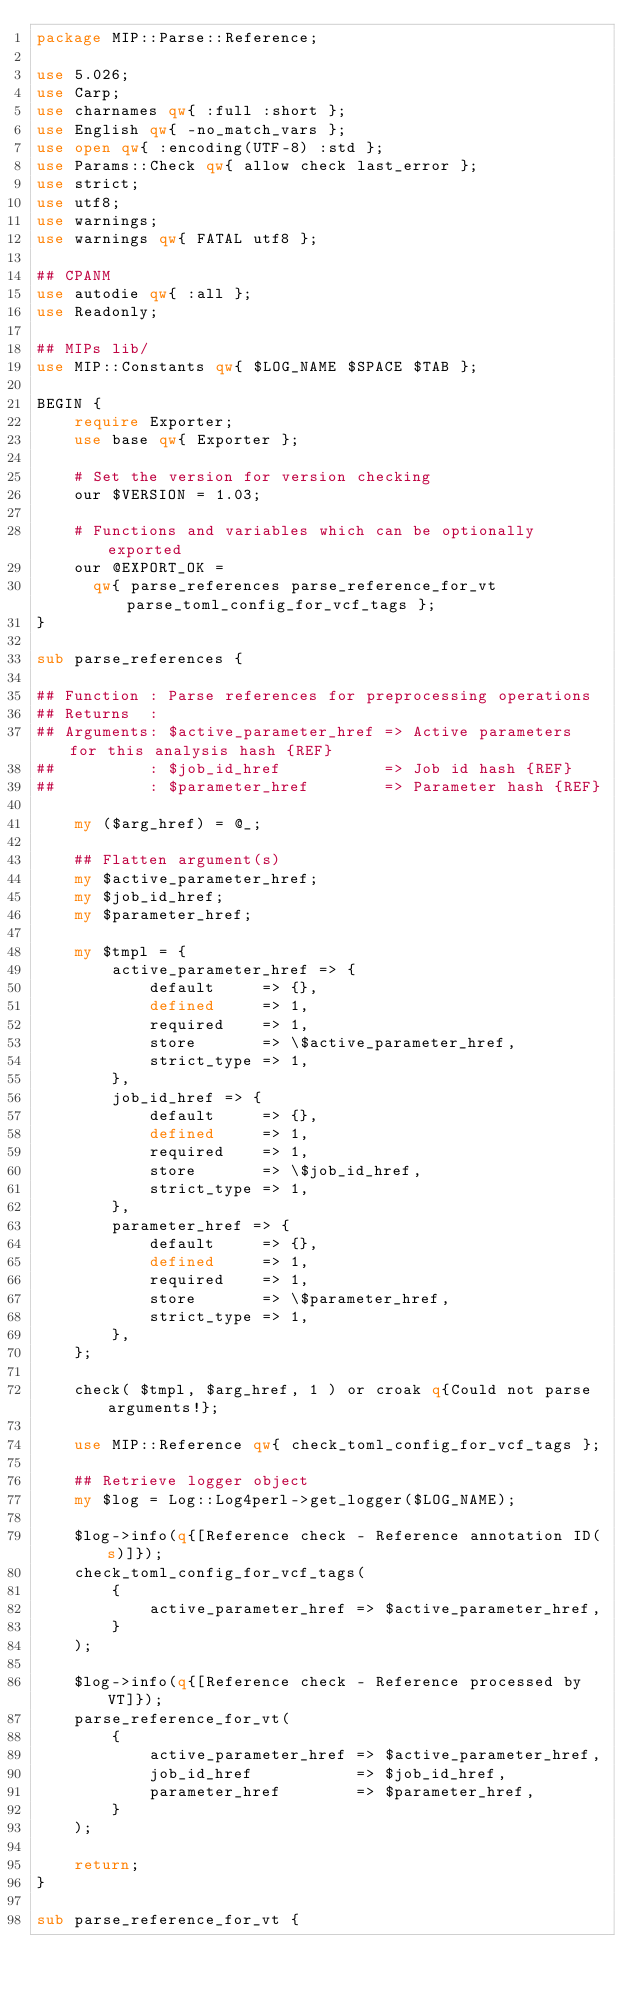Convert code to text. <code><loc_0><loc_0><loc_500><loc_500><_Perl_>package MIP::Parse::Reference;

use 5.026;
use Carp;
use charnames qw{ :full :short };
use English qw{ -no_match_vars };
use open qw{ :encoding(UTF-8) :std };
use Params::Check qw{ allow check last_error };
use strict;
use utf8;
use warnings;
use warnings qw{ FATAL utf8 };

## CPANM
use autodie qw{ :all };
use Readonly;

## MIPs lib/
use MIP::Constants qw{ $LOG_NAME $SPACE $TAB };

BEGIN {
    require Exporter;
    use base qw{ Exporter };

    # Set the version for version checking
    our $VERSION = 1.03;

    # Functions and variables which can be optionally exported
    our @EXPORT_OK =
      qw{ parse_references parse_reference_for_vt parse_toml_config_for_vcf_tags };
}

sub parse_references {

## Function : Parse references for preprocessing operations
## Returns  :
## Arguments: $active_parameter_href => Active parameters for this analysis hash {REF}
##          : $job_id_href           => Job id hash {REF}
##          : $parameter_href        => Parameter hash {REF}

    my ($arg_href) = @_;

    ## Flatten argument(s)
    my $active_parameter_href;
    my $job_id_href;
    my $parameter_href;

    my $tmpl = {
        active_parameter_href => {
            default     => {},
            defined     => 1,
            required    => 1,
            store       => \$active_parameter_href,
            strict_type => 1,
        },
        job_id_href => {
            default     => {},
            defined     => 1,
            required    => 1,
            store       => \$job_id_href,
            strict_type => 1,
        },
        parameter_href => {
            default     => {},
            defined     => 1,
            required    => 1,
            store       => \$parameter_href,
            strict_type => 1,
        },
    };

    check( $tmpl, $arg_href, 1 ) or croak q{Could not parse arguments!};

    use MIP::Reference qw{ check_toml_config_for_vcf_tags };

    ## Retrieve logger object
    my $log = Log::Log4perl->get_logger($LOG_NAME);

    $log->info(q{[Reference check - Reference annotation ID(s)]});
    check_toml_config_for_vcf_tags(
        {
            active_parameter_href => $active_parameter_href,
        }
    );

    $log->info(q{[Reference check - Reference processed by VT]});
    parse_reference_for_vt(
        {
            active_parameter_href => $active_parameter_href,
            job_id_href           => $job_id_href,
            parameter_href        => $parameter_href,
        }
    );

    return;
}

sub parse_reference_for_vt {
</code> 